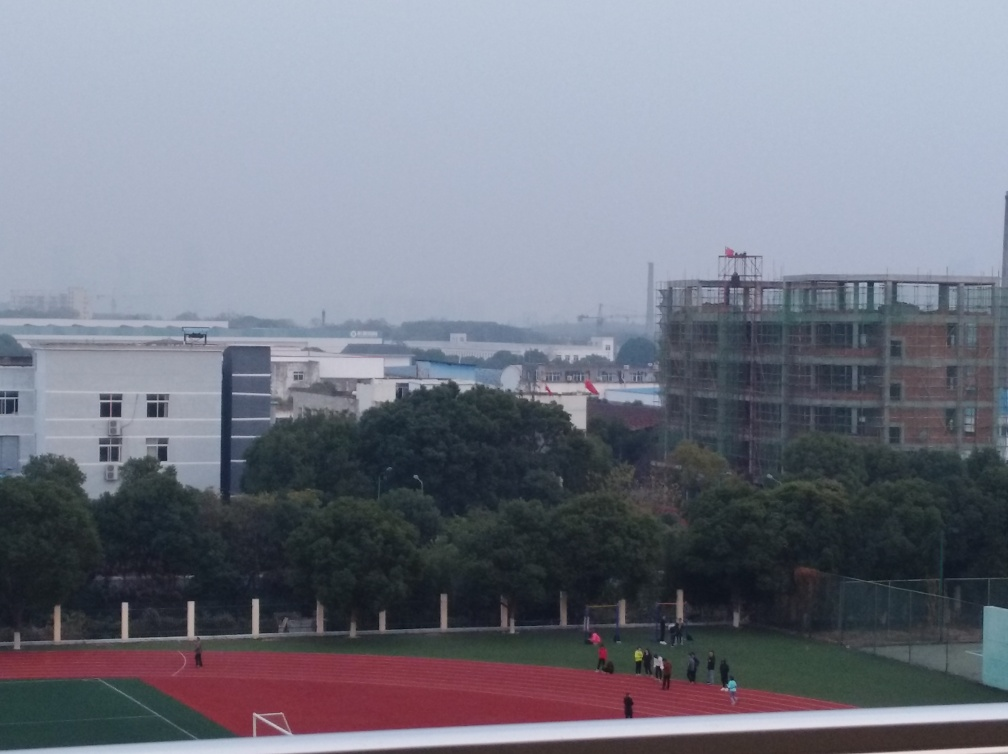What type of area does the image portray? The image depicts an urban environment, with a mix of buildings, including what appears to be a school or sports complex, given the presence of the sports field, and an ongoing construction site. The presence of foliage suggests that the area also includes landscaped spaces. 